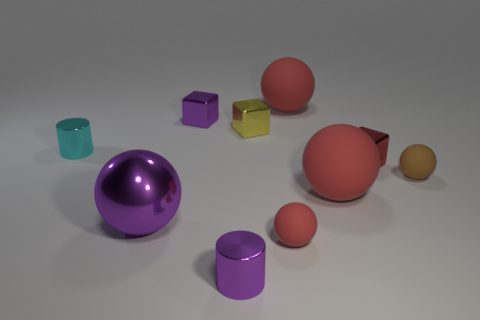Subtract all red blocks. How many red balls are left? 3 Subtract all purple balls. How many balls are left? 4 Subtract all tiny red rubber balls. How many balls are left? 4 Subtract 1 balls. How many balls are left? 4 Subtract all blue balls. Subtract all green cylinders. How many balls are left? 5 Subtract all cylinders. How many objects are left? 8 Subtract all large metallic objects. Subtract all brown matte objects. How many objects are left? 8 Add 6 metallic balls. How many metallic balls are left? 7 Add 4 small yellow metal objects. How many small yellow metal objects exist? 5 Subtract 1 yellow cubes. How many objects are left? 9 